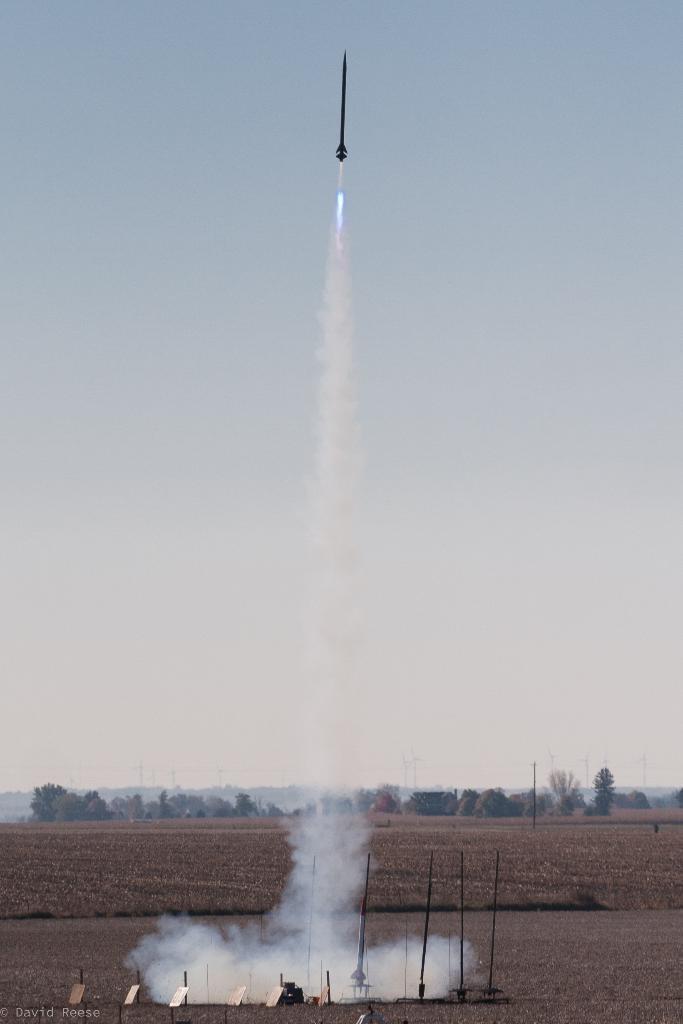Could you give a brief overview of what you see in this image? In the picture I can see a rocket is flying in the air. Here I can see poles, white smoke, trees and some other objects on the ground. In the background I can see the sky. On the bottom left corner of the image I can see a watermark. 